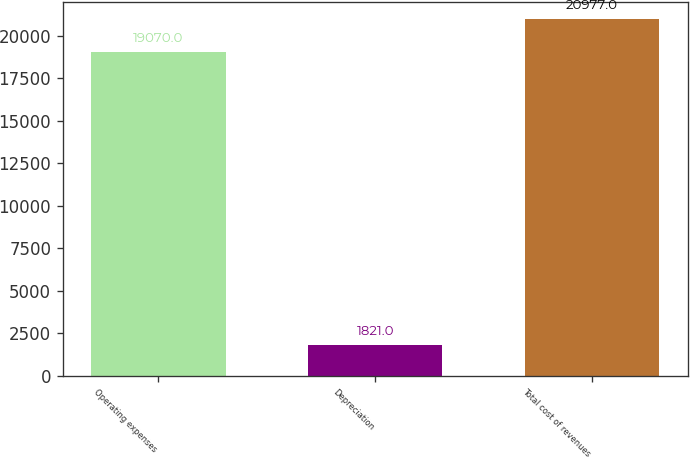Convert chart. <chart><loc_0><loc_0><loc_500><loc_500><bar_chart><fcel>Operating expenses<fcel>Depreciation<fcel>Total cost of revenues<nl><fcel>19070<fcel>1821<fcel>20977<nl></chart> 